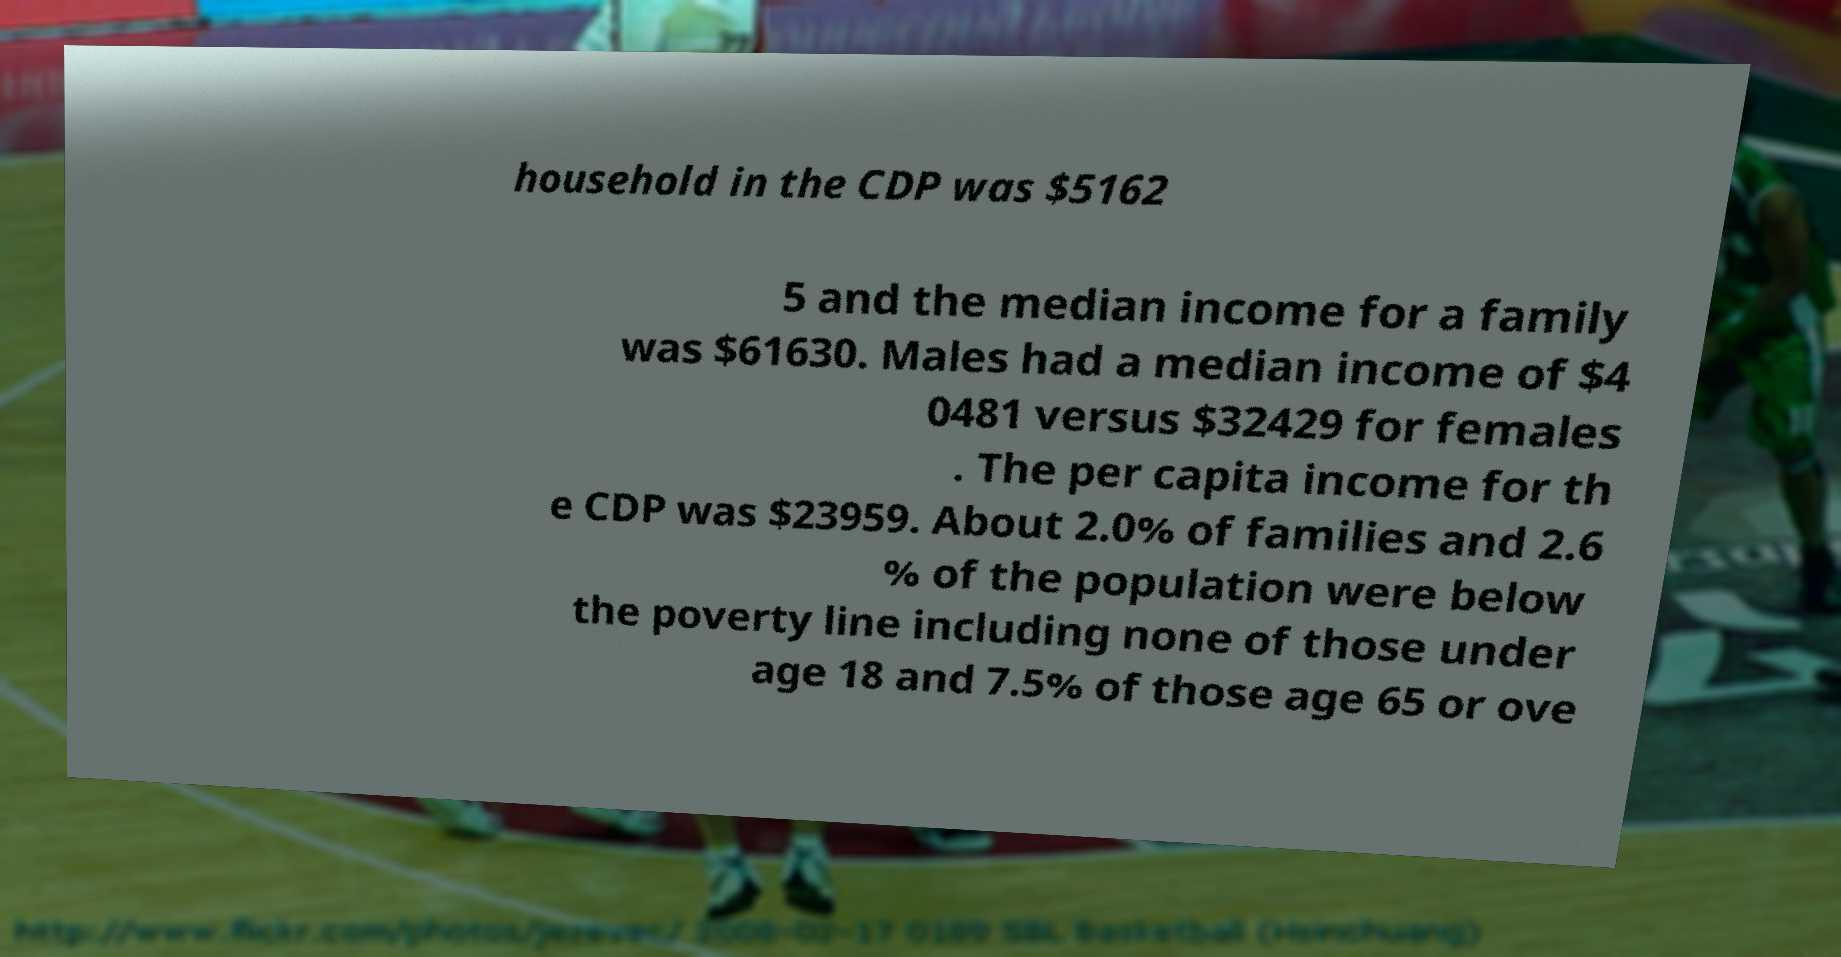Please read and relay the text visible in this image. What does it say? household in the CDP was $5162 5 and the median income for a family was $61630. Males had a median income of $4 0481 versus $32429 for females . The per capita income for th e CDP was $23959. About 2.0% of families and 2.6 % of the population were below the poverty line including none of those under age 18 and 7.5% of those age 65 or ove 